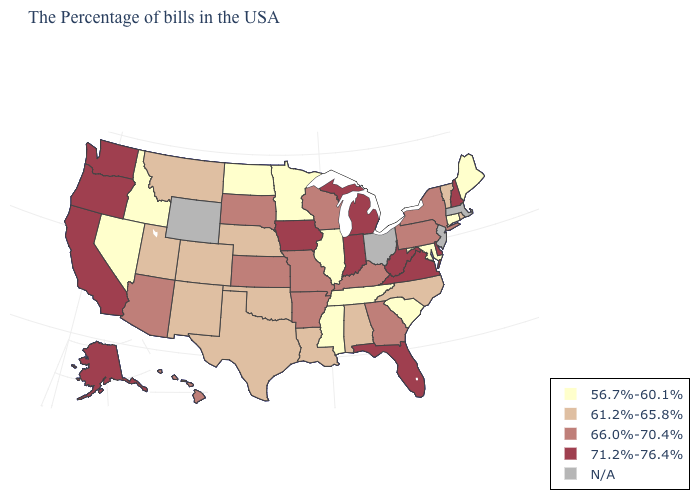Name the states that have a value in the range N/A?
Concise answer only. Massachusetts, New Jersey, Ohio, Wyoming. Is the legend a continuous bar?
Quick response, please. No. Which states have the lowest value in the West?
Short answer required. Idaho, Nevada. Name the states that have a value in the range N/A?
Concise answer only. Massachusetts, New Jersey, Ohio, Wyoming. Name the states that have a value in the range 61.2%-65.8%?
Write a very short answer. Rhode Island, Vermont, North Carolina, Alabama, Louisiana, Nebraska, Oklahoma, Texas, Colorado, New Mexico, Utah, Montana. What is the value of South Dakota?
Quick response, please. 66.0%-70.4%. What is the value of Idaho?
Short answer required. 56.7%-60.1%. Which states have the lowest value in the West?
Quick response, please. Idaho, Nevada. Name the states that have a value in the range 56.7%-60.1%?
Be succinct. Maine, Connecticut, Maryland, South Carolina, Tennessee, Illinois, Mississippi, Minnesota, North Dakota, Idaho, Nevada. Name the states that have a value in the range 61.2%-65.8%?
Quick response, please. Rhode Island, Vermont, North Carolina, Alabama, Louisiana, Nebraska, Oklahoma, Texas, Colorado, New Mexico, Utah, Montana. Does Connecticut have the lowest value in the Northeast?
Be succinct. Yes. Name the states that have a value in the range 66.0%-70.4%?
Short answer required. New York, Pennsylvania, Georgia, Kentucky, Wisconsin, Missouri, Arkansas, Kansas, South Dakota, Arizona, Hawaii. Name the states that have a value in the range 56.7%-60.1%?
Concise answer only. Maine, Connecticut, Maryland, South Carolina, Tennessee, Illinois, Mississippi, Minnesota, North Dakota, Idaho, Nevada. Which states hav the highest value in the South?
Write a very short answer. Delaware, Virginia, West Virginia, Florida. 